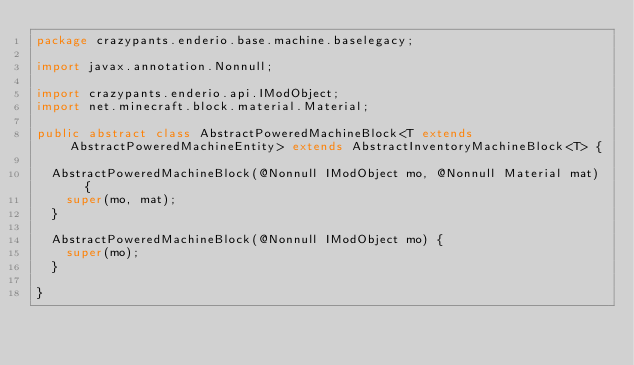Convert code to text. <code><loc_0><loc_0><loc_500><loc_500><_Java_>package crazypants.enderio.base.machine.baselegacy;

import javax.annotation.Nonnull;

import crazypants.enderio.api.IModObject;
import net.minecraft.block.material.Material;

public abstract class AbstractPoweredMachineBlock<T extends AbstractPoweredMachineEntity> extends AbstractInventoryMachineBlock<T> {

  AbstractPoweredMachineBlock(@Nonnull IModObject mo, @Nonnull Material mat) {
    super(mo, mat);
  }

  AbstractPoweredMachineBlock(@Nonnull IModObject mo) {
    super(mo);
  }

}
</code> 